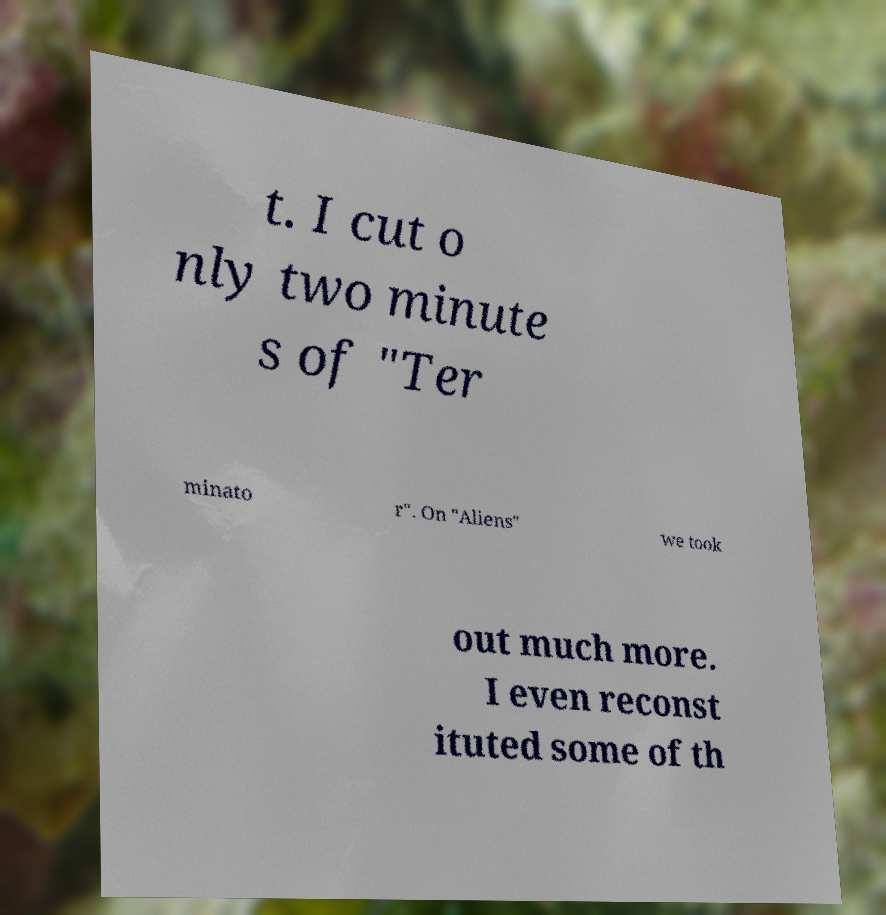For documentation purposes, I need the text within this image transcribed. Could you provide that? t. I cut o nly two minute s of "Ter minato r". On "Aliens" we took out much more. I even reconst ituted some of th 